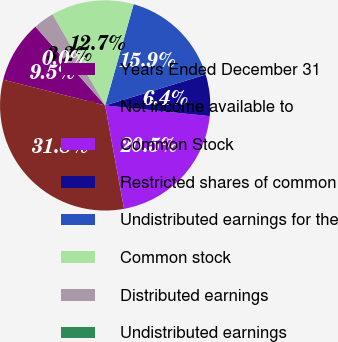Convert chart to OTSL. <chart><loc_0><loc_0><loc_500><loc_500><pie_chart><fcel>Years Ended December 31<fcel>Net income available to<fcel>Common Stock<fcel>Restricted shares of common<fcel>Undistributed earnings for the<fcel>Common stock<fcel>Distributed earnings<fcel>Undistributed earnings<nl><fcel>9.54%<fcel>31.8%<fcel>20.5%<fcel>6.36%<fcel>15.9%<fcel>12.72%<fcel>3.18%<fcel>0.0%<nl></chart> 